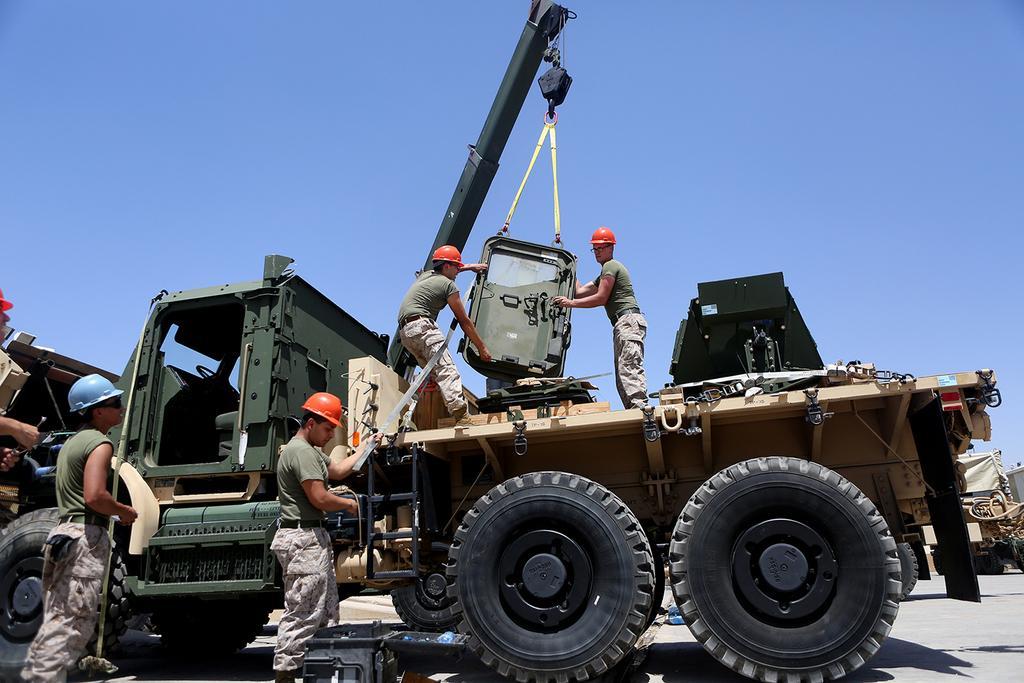Could you give a brief overview of what you see in this image? In this picture I can see a vehicle on which I can see two men are holding an object. Here I can see some other people are standing and holding some objects in their hands. In the background I can see the sky. On the right side I can see some other objects. 